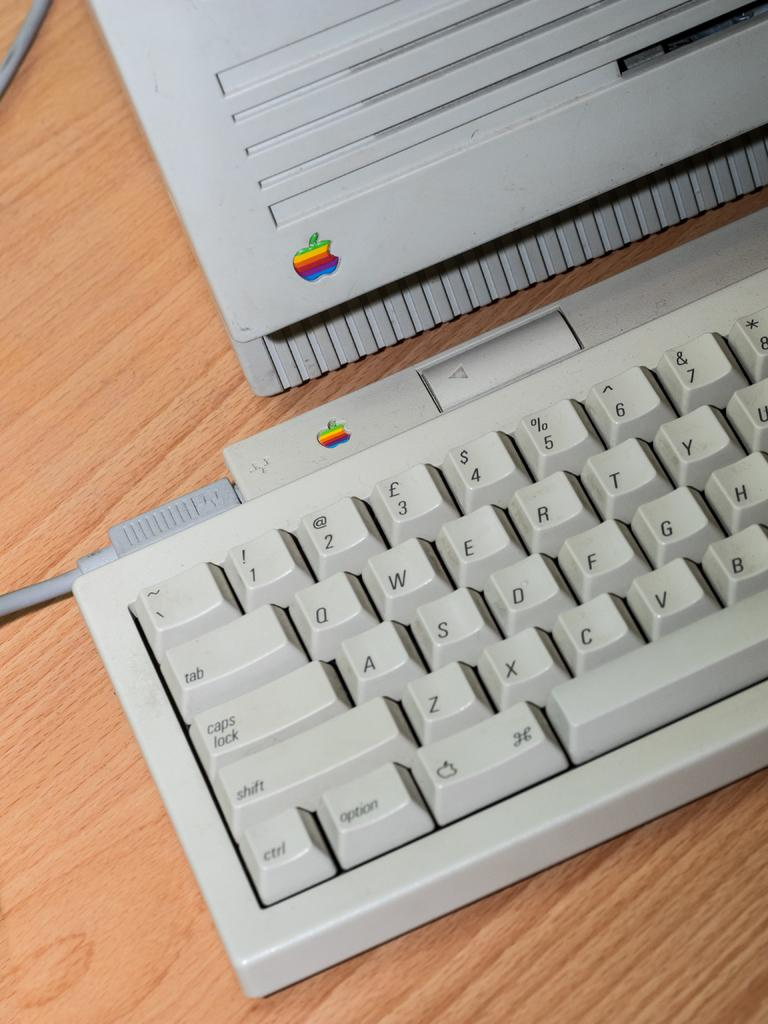What is the focus of the image? The image is a zoomed-in view. What can be seen in the foreground of the image? There is a wooden table in the foreground. What electronic devices are placed on the table? A laptop and a keyboard are placed on the table. What else is present on the table? A cable is present on the table. What type of wine is stored in the cellar beneath the table in the image? There is no cellar or wine present in the image; it only features a wooden table with a laptop, keyboard, and cable. 